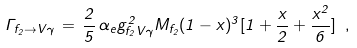Convert formula to latex. <formula><loc_0><loc_0><loc_500><loc_500>\Gamma _ { f _ { 2 } \rightarrow V \gamma } \, = \, \frac { 2 } { 5 } \, \alpha _ { e } g _ { f _ { 2 } V \gamma } ^ { 2 } M _ { f _ { 2 } } ( 1 - x ) ^ { 3 } [ 1 + \frac { x } { 2 } + \frac { x ^ { 2 } } { 6 } ] \ ,</formula> 